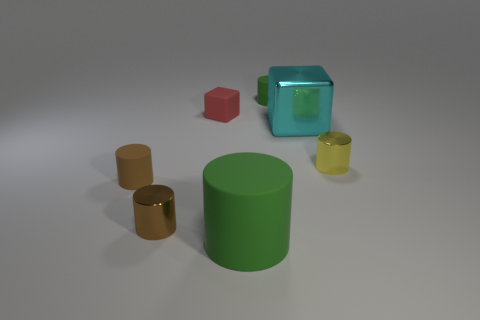Subtract all yellow cylinders. How many cylinders are left? 4 Subtract all big green rubber cylinders. How many cylinders are left? 4 Subtract all red cylinders. Subtract all yellow balls. How many cylinders are left? 5 Add 2 blue metal blocks. How many objects exist? 9 Subtract all blocks. How many objects are left? 5 Add 6 yellow metal spheres. How many yellow metal spheres exist? 6 Subtract 0 red spheres. How many objects are left? 7 Subtract all brown shiny blocks. Subtract all large cyan things. How many objects are left? 6 Add 2 brown shiny things. How many brown shiny things are left? 3 